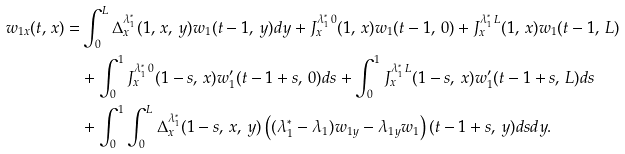<formula> <loc_0><loc_0><loc_500><loc_500>w _ { 1 x } ( t , \, x ) = & \int _ { 0 } ^ { L } \Delta ^ { \lambda _ { 1 } ^ { \ast } } _ { x } ( 1 , \, x , \, y ) w _ { 1 } ( t - 1 , \, y ) d y + J _ { x } ^ { \lambda _ { 1 } ^ { \ast } \, 0 } ( 1 , \, x ) w _ { 1 } ( t - 1 , \, 0 ) + J _ { x } ^ { \lambda _ { 1 } ^ { \ast } \, L } ( 1 , \, x ) w _ { 1 } ( t - 1 , \, L ) \\ & + \int _ { 0 } ^ { 1 } J _ { x } ^ { \lambda _ { 1 } ^ { \ast } \, 0 } ( 1 - s , \, x ) w _ { 1 } ^ { \prime } ( t - 1 + s , \, 0 ) d s + \int _ { 0 } ^ { 1 } J _ { x } ^ { \lambda _ { 1 } ^ { \ast } \, L } ( 1 - s , \, x ) w _ { 1 } ^ { \prime } ( t - 1 + s , \, L ) d s \\ & + \int _ { 0 } ^ { 1 } \int _ { 0 } ^ { L } \Delta ^ { \lambda _ { 1 } ^ { \ast } } _ { x } ( 1 - s , \, x , \, y ) \left ( ( \lambda _ { 1 } ^ { \ast } - \lambda _ { 1 } ) w _ { 1 y } - \lambda _ { 1 y } w _ { 1 } \right ) ( t - 1 + s , \, y ) d s d y . \\</formula> 